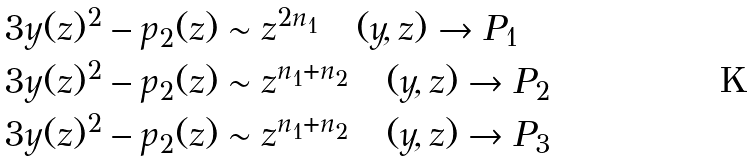Convert formula to latex. <formula><loc_0><loc_0><loc_500><loc_500>& 3 y ( z ) ^ { 2 } - p _ { 2 } ( z ) \sim z ^ { 2 n _ { 1 } } \quad ( y , z ) \rightarrow P _ { 1 } \\ & 3 y ( z ) ^ { 2 } - p _ { 2 } ( z ) \sim z ^ { n _ { 1 } + n _ { 2 } } \quad ( y , z ) \rightarrow P _ { 2 } \\ & 3 y ( z ) ^ { 2 } - p _ { 2 } ( z ) \sim z ^ { n _ { 1 } + n _ { 2 } } \quad ( y , z ) \rightarrow P _ { 3 }</formula> 